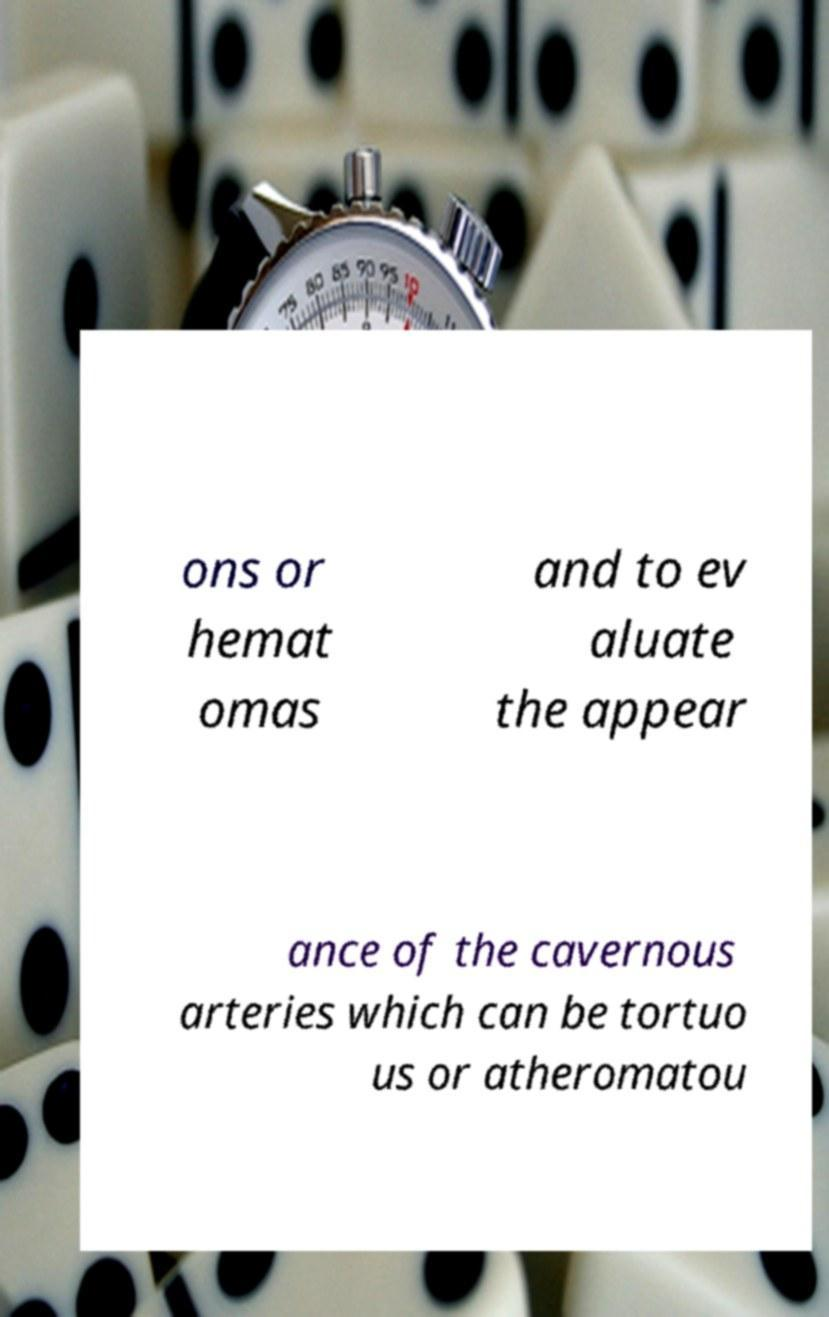I need the written content from this picture converted into text. Can you do that? ons or hemat omas and to ev aluate the appear ance of the cavernous arteries which can be tortuo us or atheromatou 